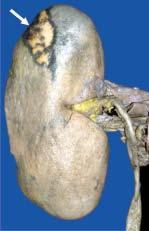s amyloid on the surface?
Answer the question using a single word or phrase. No 